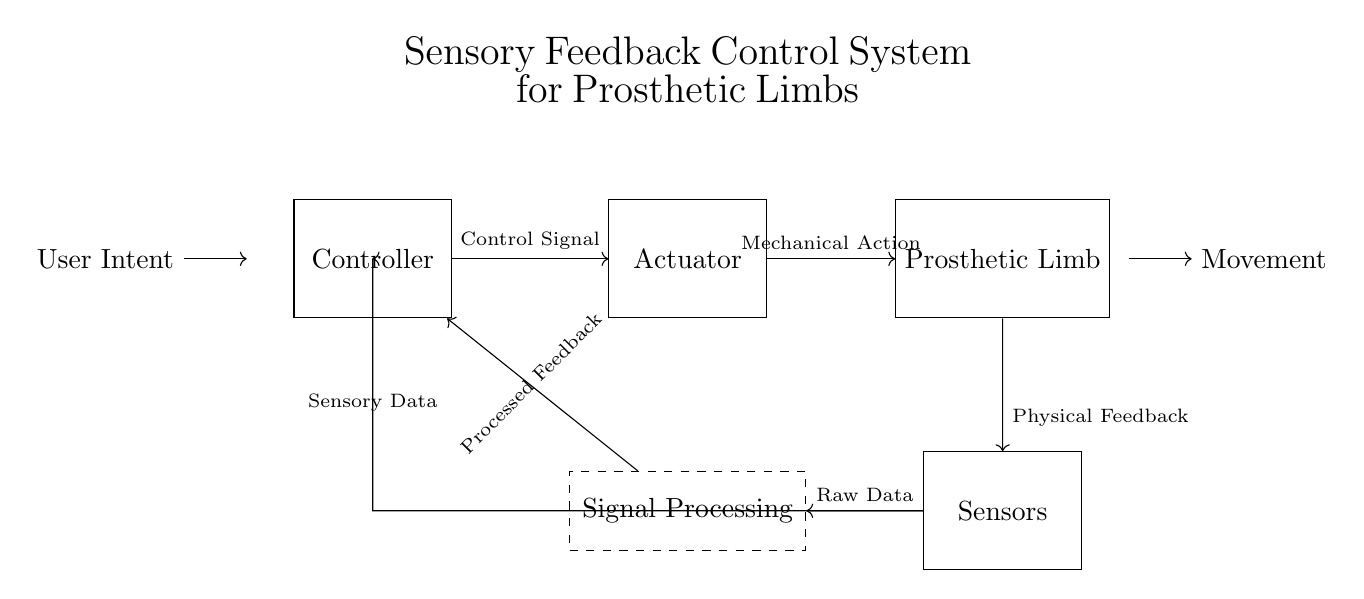what is the main component that receives user intent? The user intent is received by the Controller, which is the first component in the circuit diagram. It serves as the input for the entire system.
Answer: Controller what type of data is sent from the sensors to the controller? The data sent from the sensors to the controller is called Sensory Data. This transfer signifies the feedback loop where physical feedback from the prosthetic limb is communicated back to the control system.
Answer: Sensory Data what component acts upon the control signal? The Actuator acts upon the Control Signal sent from the Controller. The Actuator translates the control command into a physical action which drives the movement of the prosthetic limb.
Answer: Actuator describe the function of the processing unit in the system. The Signal Processing unit takes in Raw Data from the sensors, processes it to extract useful information, and then sends Processed Feedback to the Controller to adjust the Control Signal as necessary. This helps in refining the user experience by making the prosthetic limb's responses more accurate and timely.
Answer: Signal Processing how does the physical feedback from the prosthetic limb influence the system? The Physical Feedback from the prosthetic limb is crucial for creating a feedback loop. It informs the Sensors about the current status of the limb, which is then relayed to the Controller as Sensory Data, allowing for real-time adjustments to enhance control and responsiveness.
Answer: It creates a feedback loop what mechanism connects the sensors and the processing unit? The mechanism connecting the sensors and the processing unit is a direct line indicated by the arrow in the diagram, representing the flow of Raw Data from the Sensors to the Signal Processing unit for analysis.
Answer: Direct line what type of control system is represented in this circuit? This circuit represents a sensory feedback control system specifically designed for prosthetic limbs, which integrates user intent, mechanical action, and sensory feedback to improve user experience.
Answer: Sensory feedback control system 